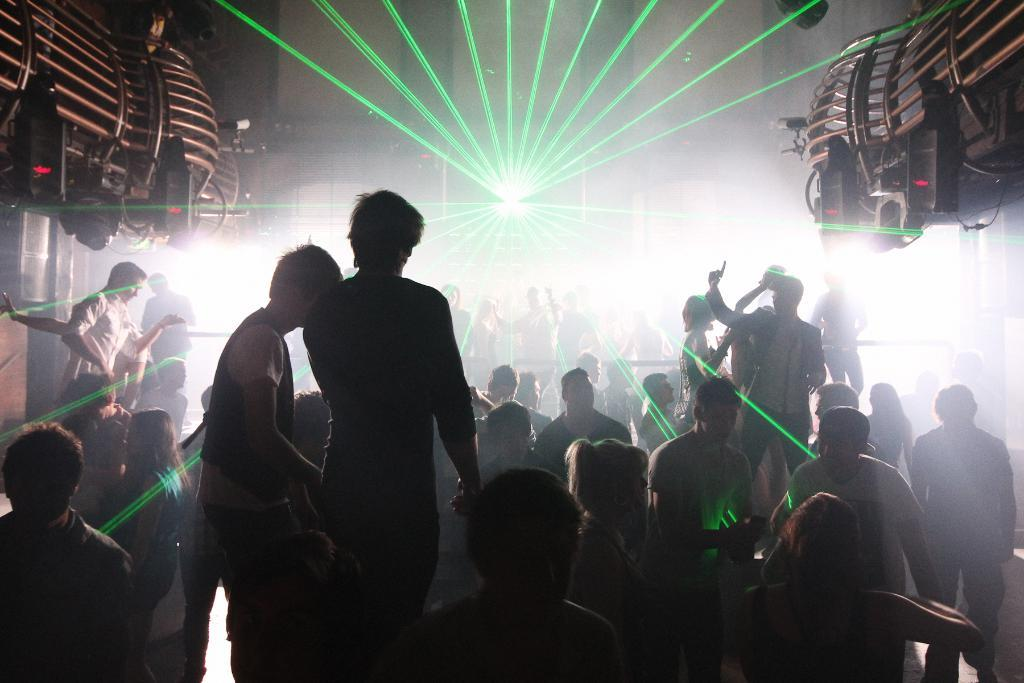What can be seen in the image in terms of human presence? There are groups of people in the image. Are there any objects present in the image besides the people? Yes, there are objects at the top left and right sides of the image. What is the nature of the image, which is the presence of people? The people are gathered together, possibly for an event or activity. What can be seen behind the people in the image? There is a laser light visible behind the people. What type of shelf can be seen in the image? There is no shelf present in the image. 